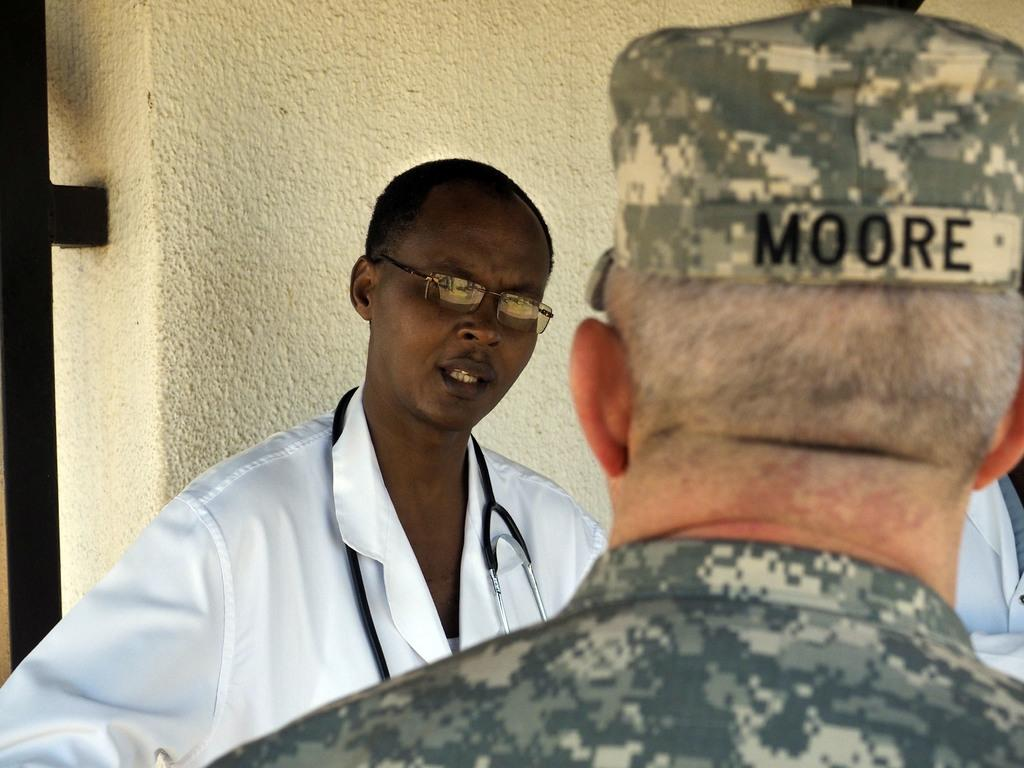What can be seen in the image? There are people standing in the image. What is visible in the background of the image? There is a wall in the background of the image. What type of ray can be seen flying over the people in the image? There is no ray present in the image; it only features people standing and a wall in the background. 